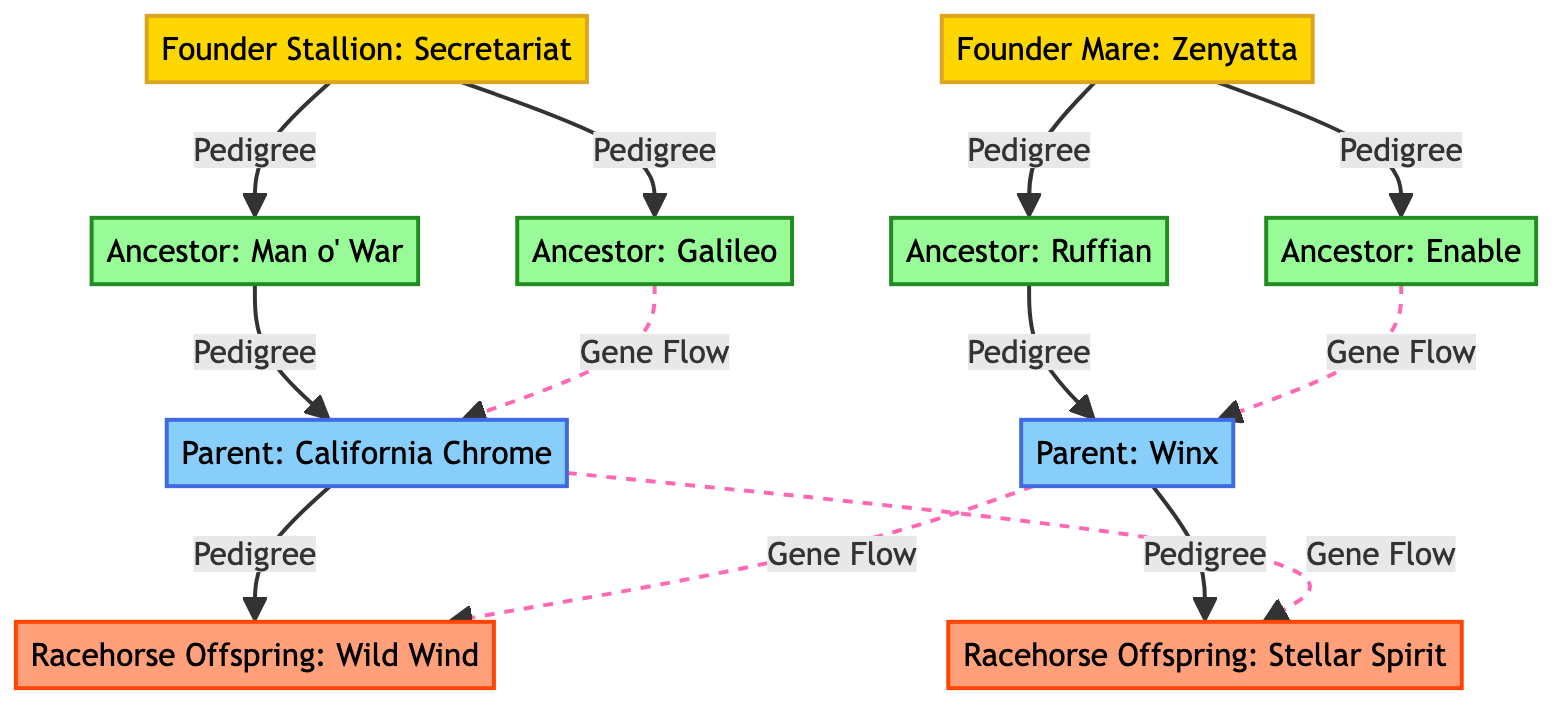What are the names of the two founders in the diagram? The diagram lists two founder nodes: "Founder Stallion: Secretariat" and "Founder Mare: Zenyatta". These are represented at the top of the diagram.
Answer: Secretariat, Zenyatta How many ancestors are shown in the diagram? The diagram contains four ancestor nodes, which are "Man o' War", "Ruffian", "Galileo", and "Enable". These nodes are linked to the founders.
Answer: 4 Which ancestor is connected to the parent "California Chrome"? The diagram shows that "California Chrome" is connected to "Man o' War" through a direct pedigree link. This means "Man o' War" is one of California Chrome's ancestors.
Answer: Man o' War What type of links connect the ancestors to the parents? The links connecting ancestors to parents are labeled as "Pedigree", which means they represent a direct lineage relationship between these nodes.
Answer: Pedigree Which two racehorse offspring are represented in the diagram? The racehorse offspring depicted in the diagram are "Wild Wind" and "Stellar Spirit". These nodes are at the bottom of the diagram and connected to their respective parents.
Answer: Wild Wind, Stellar Spirit How is gene flow represented in the diagram? Gene flow is represented using dashed lines, indicated as "Gene Flow" connections. In the diagram, this includes interactions between ancestors and parents as well as between parents and offspring.
Answer: Dashed lines Which ancestor is connected to the parent "Winx"? The diagram shows that "Winx" is connected through a pedigree link to "Ruffian", making her one of Winx's ancestors shown in the diagram.
Answer: Ruffian How many offspring are there from the two parents? The diagram illustrates that there are two offspring, specifically connected to their respective parents through pedigree links.
Answer: 2 